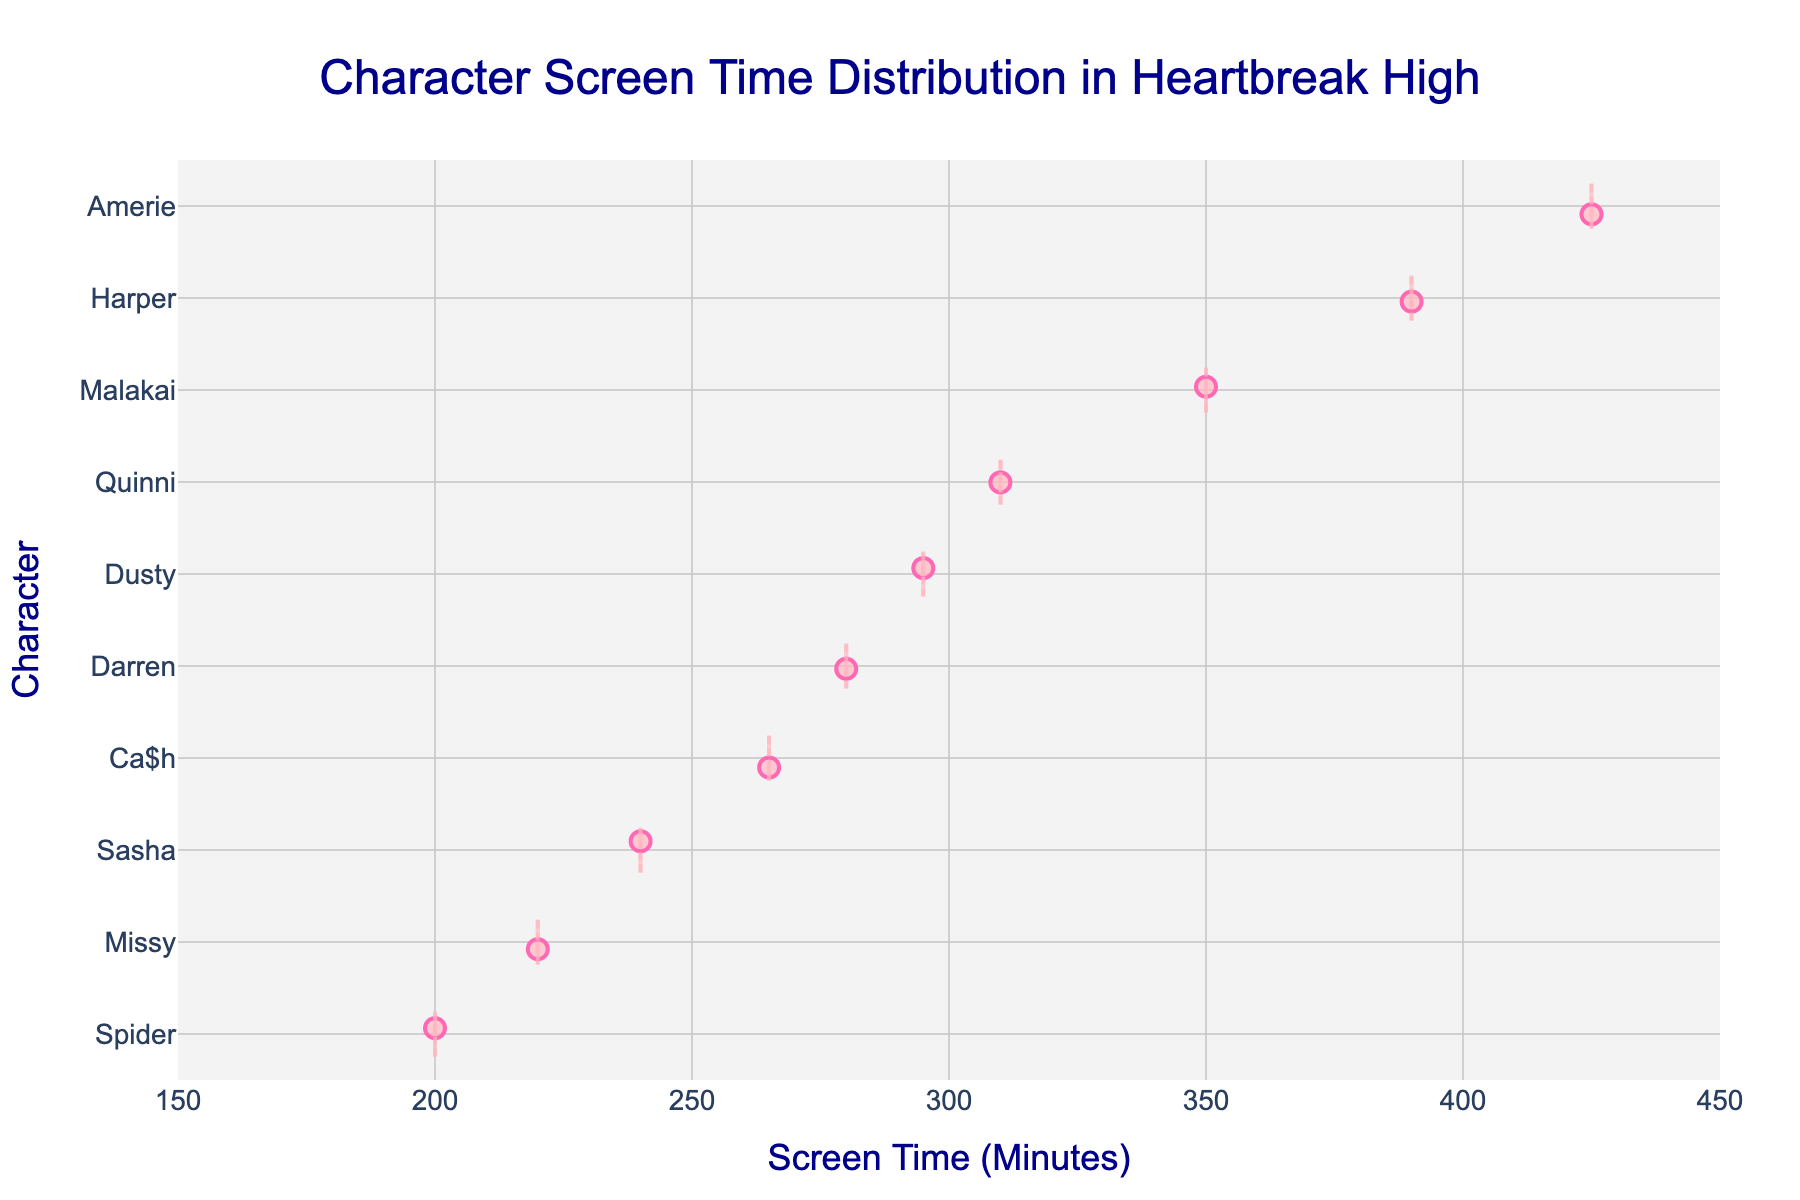What's the title of the figure? The title of the figure is located at the top of the plot and it provides a summary of what the plot represents. It reads: "Character Screen Time Distribution in Heartbreak High".
Answer: Character Screen Time Distribution in Heartbreak High Which character has the highest screen time? By observing the horizontal position of the dots and boxes, the character with the highest value is located at the far right end of the plot. This character is Amerie with a screen time of 425 minutes.
Answer: Amerie How does Malakai's screen time compare to Harper's? By comparing the positions of Malakai's and Harper's screen time values on the x-axis, we see that Malakai has a screen time of 350 minutes, while Harper has a screen time of 390 minutes. Thus, Harper has more screen time than Malakai.
Answer: Harper has more screen time What is the median value for the box around Darren's screen time? The median value is represented by the line inside the box for each character. For Darren, the screen time value at this line is approximately 280 minutes.
Answer: 280 minutes Identify the character with the lowest screen time By observing the character with the point closest to the left end of the x-axis, we see that the character with the shortest screen time is Spider at 200 minutes.
Answer: Spider Who has more screen time, Quinni or Ca$h? By comparing the positions of the dots and boxes, Quinni's screen time is 310 minutes and Ca$h's screen time is 265 minutes, indicating that Quinni has more screen time.
Answer: Quinni Calculate the range of screen times for the characters The character with the highest screen time is Amerie at 425 minutes, and the character with the lowest screen time is Spider at 200 minutes. The range is calculated as the difference: 425 - 200 = 225 minutes.
Answer: 225 minutes Which characters have a screen time greater than 300 minutes? By identifying all characters whose screen time points are located beyond the 300-minute mark on the x-axis, we find Amerie, Harper, Quinni, and Malakai all have screen times greater than 300 minutes.
Answer: Amerie, Harper, Quinni, Malakai 